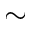<formula> <loc_0><loc_0><loc_500><loc_500>\sim</formula> 